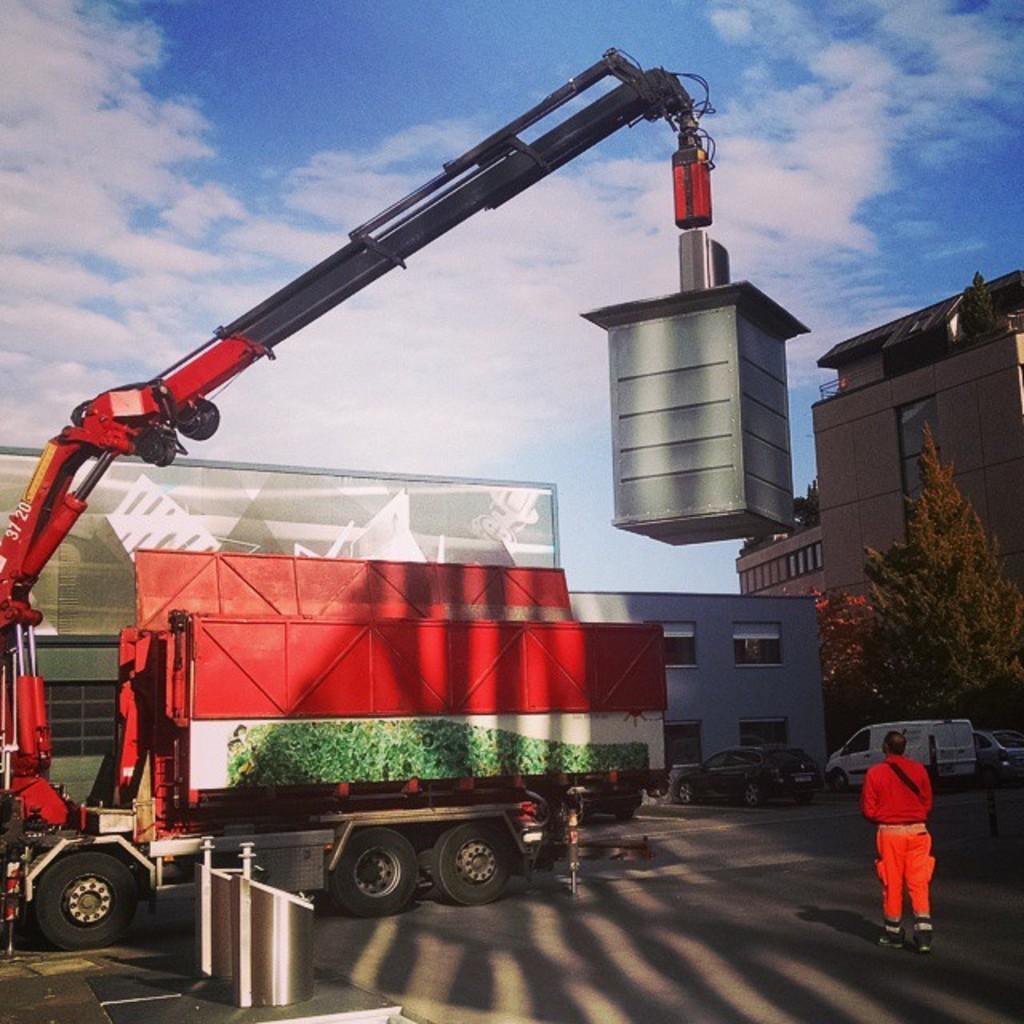What are the numbers on the arm of that crane?
Offer a terse response. 3720. 